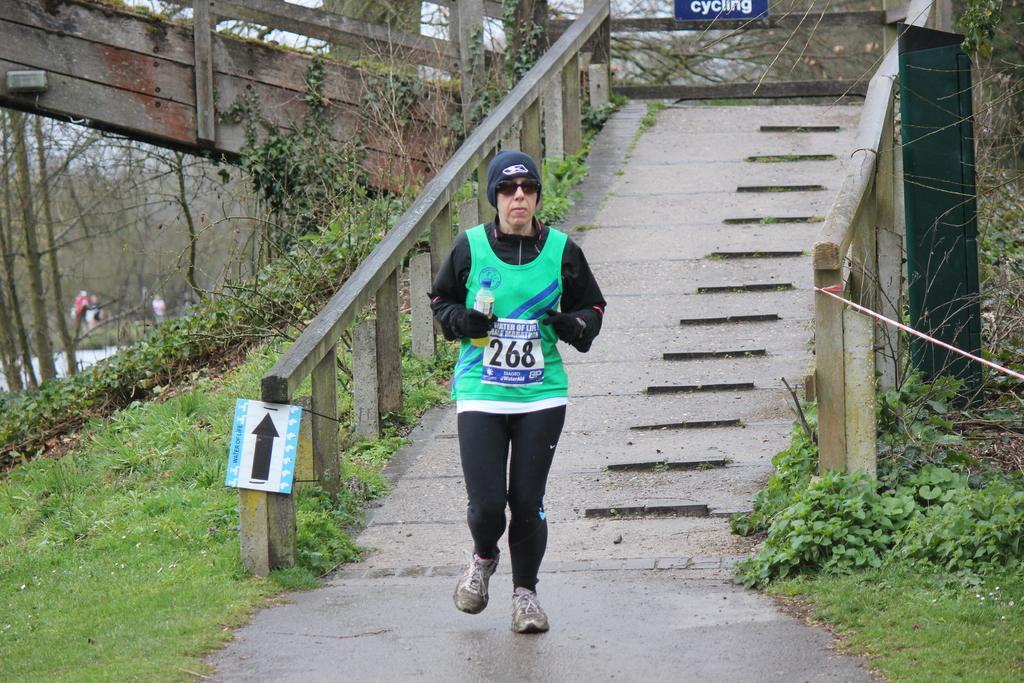Can you describe this image briefly? In this image we can see one person running and holding an object, we can see a bridge railing, trees, grass, on the right there is an object, we can see the sky in the background. 